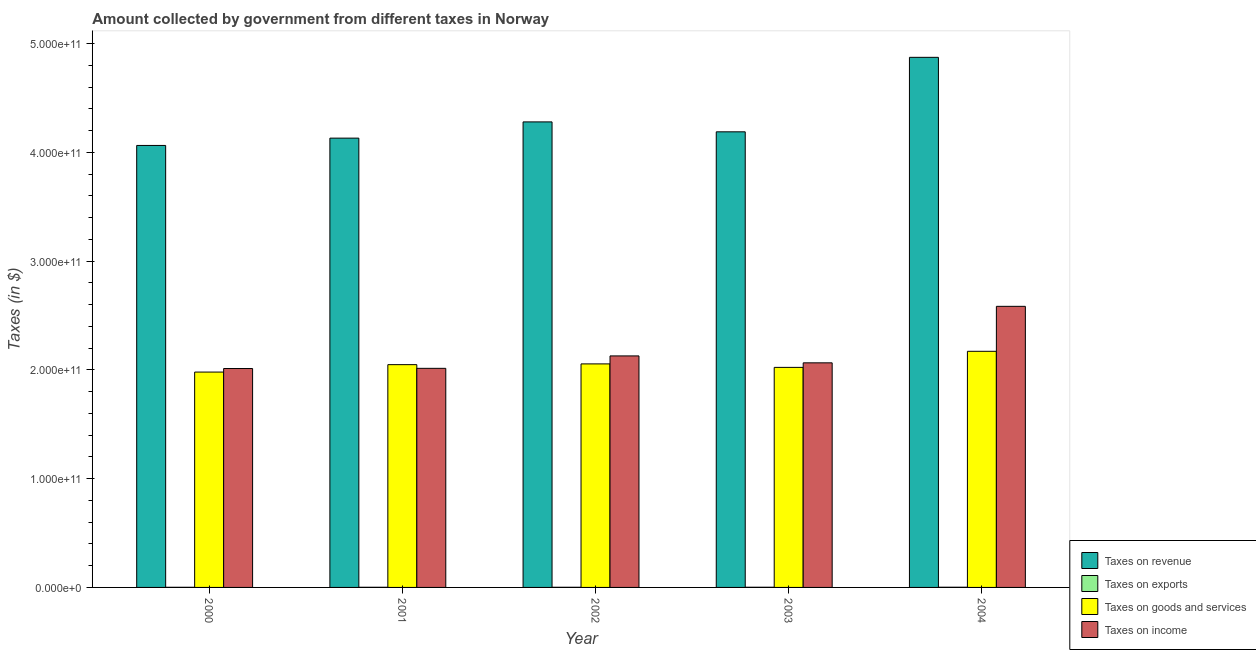How many groups of bars are there?
Give a very brief answer. 5. Are the number of bars on each tick of the X-axis equal?
Your response must be concise. Yes. How many bars are there on the 3rd tick from the right?
Keep it short and to the point. 4. What is the label of the 3rd group of bars from the left?
Offer a very short reply. 2002. What is the amount collected as tax on goods in 2003?
Offer a terse response. 2.02e+11. Across all years, what is the maximum amount collected as tax on exports?
Your response must be concise. 1.70e+08. Across all years, what is the minimum amount collected as tax on exports?
Your response must be concise. 1.10e+08. In which year was the amount collected as tax on income maximum?
Make the answer very short. 2004. What is the total amount collected as tax on revenue in the graph?
Give a very brief answer. 2.15e+12. What is the difference between the amount collected as tax on income in 2003 and that in 2004?
Make the answer very short. -5.19e+1. What is the difference between the amount collected as tax on exports in 2002 and the amount collected as tax on income in 2001?
Give a very brief answer. 1.00e+07. What is the average amount collected as tax on income per year?
Provide a short and direct response. 2.16e+11. In how many years, is the amount collected as tax on revenue greater than 40000000000 $?
Give a very brief answer. 5. What is the ratio of the amount collected as tax on income in 2002 to that in 2003?
Provide a succinct answer. 1.03. Is the amount collected as tax on goods in 2002 less than that in 2004?
Your answer should be very brief. Yes. Is the difference between the amount collected as tax on income in 2001 and 2004 greater than the difference between the amount collected as tax on revenue in 2001 and 2004?
Your response must be concise. No. What is the difference between the highest and the second highest amount collected as tax on goods?
Give a very brief answer. 1.16e+1. What is the difference between the highest and the lowest amount collected as tax on income?
Keep it short and to the point. 5.72e+1. What does the 4th bar from the left in 2001 represents?
Offer a terse response. Taxes on income. What does the 3rd bar from the right in 2004 represents?
Offer a terse response. Taxes on exports. Is it the case that in every year, the sum of the amount collected as tax on revenue and amount collected as tax on exports is greater than the amount collected as tax on goods?
Give a very brief answer. Yes. How many bars are there?
Offer a very short reply. 20. What is the difference between two consecutive major ticks on the Y-axis?
Ensure brevity in your answer.  1.00e+11. Does the graph contain grids?
Your answer should be very brief. No. Where does the legend appear in the graph?
Keep it short and to the point. Bottom right. How many legend labels are there?
Your response must be concise. 4. How are the legend labels stacked?
Give a very brief answer. Vertical. What is the title of the graph?
Your response must be concise. Amount collected by government from different taxes in Norway. Does "Korea" appear as one of the legend labels in the graph?
Give a very brief answer. No. What is the label or title of the X-axis?
Keep it short and to the point. Year. What is the label or title of the Y-axis?
Your answer should be very brief. Taxes (in $). What is the Taxes (in $) in Taxes on revenue in 2000?
Give a very brief answer. 4.06e+11. What is the Taxes (in $) in Taxes on exports in 2000?
Keep it short and to the point. 1.10e+08. What is the Taxes (in $) of Taxes on goods and services in 2000?
Provide a short and direct response. 1.98e+11. What is the Taxes (in $) of Taxes on income in 2000?
Your answer should be compact. 2.01e+11. What is the Taxes (in $) of Taxes on revenue in 2001?
Make the answer very short. 4.13e+11. What is the Taxes (in $) in Taxes on exports in 2001?
Your answer should be compact. 1.20e+08. What is the Taxes (in $) of Taxes on goods and services in 2001?
Give a very brief answer. 2.05e+11. What is the Taxes (in $) in Taxes on income in 2001?
Your answer should be compact. 2.01e+11. What is the Taxes (in $) in Taxes on revenue in 2002?
Offer a terse response. 4.28e+11. What is the Taxes (in $) of Taxes on exports in 2002?
Keep it short and to the point. 1.30e+08. What is the Taxes (in $) of Taxes on goods and services in 2002?
Give a very brief answer. 2.06e+11. What is the Taxes (in $) in Taxes on income in 2002?
Keep it short and to the point. 2.13e+11. What is the Taxes (in $) of Taxes on revenue in 2003?
Offer a terse response. 4.19e+11. What is the Taxes (in $) in Taxes on exports in 2003?
Make the answer very short. 1.50e+08. What is the Taxes (in $) of Taxes on goods and services in 2003?
Give a very brief answer. 2.02e+11. What is the Taxes (in $) in Taxes on income in 2003?
Ensure brevity in your answer.  2.06e+11. What is the Taxes (in $) in Taxes on revenue in 2004?
Make the answer very short. 4.87e+11. What is the Taxes (in $) of Taxes on exports in 2004?
Offer a very short reply. 1.70e+08. What is the Taxes (in $) in Taxes on goods and services in 2004?
Make the answer very short. 2.17e+11. What is the Taxes (in $) of Taxes on income in 2004?
Provide a short and direct response. 2.58e+11. Across all years, what is the maximum Taxes (in $) of Taxes on revenue?
Offer a very short reply. 4.87e+11. Across all years, what is the maximum Taxes (in $) in Taxes on exports?
Keep it short and to the point. 1.70e+08. Across all years, what is the maximum Taxes (in $) in Taxes on goods and services?
Your response must be concise. 2.17e+11. Across all years, what is the maximum Taxes (in $) of Taxes on income?
Your answer should be compact. 2.58e+11. Across all years, what is the minimum Taxes (in $) in Taxes on revenue?
Provide a short and direct response. 4.06e+11. Across all years, what is the minimum Taxes (in $) of Taxes on exports?
Make the answer very short. 1.10e+08. Across all years, what is the minimum Taxes (in $) of Taxes on goods and services?
Offer a very short reply. 1.98e+11. Across all years, what is the minimum Taxes (in $) in Taxes on income?
Give a very brief answer. 2.01e+11. What is the total Taxes (in $) in Taxes on revenue in the graph?
Offer a terse response. 2.15e+12. What is the total Taxes (in $) in Taxes on exports in the graph?
Give a very brief answer. 6.80e+08. What is the total Taxes (in $) of Taxes on goods and services in the graph?
Provide a short and direct response. 1.03e+12. What is the total Taxes (in $) of Taxes on income in the graph?
Your response must be concise. 1.08e+12. What is the difference between the Taxes (in $) in Taxes on revenue in 2000 and that in 2001?
Offer a terse response. -6.72e+09. What is the difference between the Taxes (in $) of Taxes on exports in 2000 and that in 2001?
Provide a succinct answer. -1.00e+07. What is the difference between the Taxes (in $) of Taxes on goods and services in 2000 and that in 2001?
Provide a short and direct response. -6.82e+09. What is the difference between the Taxes (in $) of Taxes on income in 2000 and that in 2001?
Your answer should be very brief. -1.79e+08. What is the difference between the Taxes (in $) of Taxes on revenue in 2000 and that in 2002?
Provide a succinct answer. -2.16e+1. What is the difference between the Taxes (in $) of Taxes on exports in 2000 and that in 2002?
Provide a short and direct response. -2.00e+07. What is the difference between the Taxes (in $) of Taxes on goods and services in 2000 and that in 2002?
Ensure brevity in your answer.  -7.52e+09. What is the difference between the Taxes (in $) of Taxes on income in 2000 and that in 2002?
Offer a very short reply. -1.16e+1. What is the difference between the Taxes (in $) in Taxes on revenue in 2000 and that in 2003?
Keep it short and to the point. -1.25e+1. What is the difference between the Taxes (in $) of Taxes on exports in 2000 and that in 2003?
Offer a terse response. -4.00e+07. What is the difference between the Taxes (in $) of Taxes on goods and services in 2000 and that in 2003?
Give a very brief answer. -4.31e+09. What is the difference between the Taxes (in $) in Taxes on income in 2000 and that in 2003?
Your answer should be compact. -5.23e+09. What is the difference between the Taxes (in $) in Taxes on revenue in 2000 and that in 2004?
Offer a terse response. -8.10e+1. What is the difference between the Taxes (in $) of Taxes on exports in 2000 and that in 2004?
Offer a terse response. -6.00e+07. What is the difference between the Taxes (in $) in Taxes on goods and services in 2000 and that in 2004?
Offer a very short reply. -1.91e+1. What is the difference between the Taxes (in $) of Taxes on income in 2000 and that in 2004?
Give a very brief answer. -5.72e+1. What is the difference between the Taxes (in $) in Taxes on revenue in 2001 and that in 2002?
Keep it short and to the point. -1.49e+1. What is the difference between the Taxes (in $) of Taxes on exports in 2001 and that in 2002?
Your response must be concise. -1.00e+07. What is the difference between the Taxes (in $) in Taxes on goods and services in 2001 and that in 2002?
Your answer should be compact. -6.98e+08. What is the difference between the Taxes (in $) in Taxes on income in 2001 and that in 2002?
Your response must be concise. -1.14e+1. What is the difference between the Taxes (in $) in Taxes on revenue in 2001 and that in 2003?
Your answer should be very brief. -5.80e+09. What is the difference between the Taxes (in $) of Taxes on exports in 2001 and that in 2003?
Offer a terse response. -3.00e+07. What is the difference between the Taxes (in $) in Taxes on goods and services in 2001 and that in 2003?
Make the answer very short. 2.51e+09. What is the difference between the Taxes (in $) of Taxes on income in 2001 and that in 2003?
Ensure brevity in your answer.  -5.05e+09. What is the difference between the Taxes (in $) of Taxes on revenue in 2001 and that in 2004?
Keep it short and to the point. -7.43e+1. What is the difference between the Taxes (in $) in Taxes on exports in 2001 and that in 2004?
Your answer should be very brief. -5.00e+07. What is the difference between the Taxes (in $) of Taxes on goods and services in 2001 and that in 2004?
Offer a very short reply. -1.23e+1. What is the difference between the Taxes (in $) of Taxes on income in 2001 and that in 2004?
Provide a succinct answer. -5.70e+1. What is the difference between the Taxes (in $) in Taxes on revenue in 2002 and that in 2003?
Provide a short and direct response. 9.12e+09. What is the difference between the Taxes (in $) of Taxes on exports in 2002 and that in 2003?
Your response must be concise. -2.00e+07. What is the difference between the Taxes (in $) in Taxes on goods and services in 2002 and that in 2003?
Your answer should be very brief. 3.21e+09. What is the difference between the Taxes (in $) in Taxes on income in 2002 and that in 2003?
Your response must be concise. 6.36e+09. What is the difference between the Taxes (in $) of Taxes on revenue in 2002 and that in 2004?
Keep it short and to the point. -5.94e+1. What is the difference between the Taxes (in $) in Taxes on exports in 2002 and that in 2004?
Your answer should be compact. -4.00e+07. What is the difference between the Taxes (in $) of Taxes on goods and services in 2002 and that in 2004?
Your answer should be very brief. -1.16e+1. What is the difference between the Taxes (in $) in Taxes on income in 2002 and that in 2004?
Your response must be concise. -4.56e+1. What is the difference between the Taxes (in $) in Taxes on revenue in 2003 and that in 2004?
Provide a short and direct response. -6.85e+1. What is the difference between the Taxes (in $) in Taxes on exports in 2003 and that in 2004?
Offer a very short reply. -2.00e+07. What is the difference between the Taxes (in $) of Taxes on goods and services in 2003 and that in 2004?
Your answer should be compact. -1.48e+1. What is the difference between the Taxes (in $) of Taxes on income in 2003 and that in 2004?
Give a very brief answer. -5.19e+1. What is the difference between the Taxes (in $) in Taxes on revenue in 2000 and the Taxes (in $) in Taxes on exports in 2001?
Your answer should be compact. 4.06e+11. What is the difference between the Taxes (in $) of Taxes on revenue in 2000 and the Taxes (in $) of Taxes on goods and services in 2001?
Ensure brevity in your answer.  2.02e+11. What is the difference between the Taxes (in $) in Taxes on revenue in 2000 and the Taxes (in $) in Taxes on income in 2001?
Offer a terse response. 2.05e+11. What is the difference between the Taxes (in $) of Taxes on exports in 2000 and the Taxes (in $) of Taxes on goods and services in 2001?
Give a very brief answer. -2.05e+11. What is the difference between the Taxes (in $) of Taxes on exports in 2000 and the Taxes (in $) of Taxes on income in 2001?
Keep it short and to the point. -2.01e+11. What is the difference between the Taxes (in $) of Taxes on goods and services in 2000 and the Taxes (in $) of Taxes on income in 2001?
Provide a succinct answer. -3.44e+09. What is the difference between the Taxes (in $) of Taxes on revenue in 2000 and the Taxes (in $) of Taxes on exports in 2002?
Your response must be concise. 4.06e+11. What is the difference between the Taxes (in $) of Taxes on revenue in 2000 and the Taxes (in $) of Taxes on goods and services in 2002?
Your response must be concise. 2.01e+11. What is the difference between the Taxes (in $) in Taxes on revenue in 2000 and the Taxes (in $) in Taxes on income in 2002?
Make the answer very short. 1.94e+11. What is the difference between the Taxes (in $) of Taxes on exports in 2000 and the Taxes (in $) of Taxes on goods and services in 2002?
Make the answer very short. -2.05e+11. What is the difference between the Taxes (in $) of Taxes on exports in 2000 and the Taxes (in $) of Taxes on income in 2002?
Offer a very short reply. -2.13e+11. What is the difference between the Taxes (in $) in Taxes on goods and services in 2000 and the Taxes (in $) in Taxes on income in 2002?
Offer a very short reply. -1.49e+1. What is the difference between the Taxes (in $) in Taxes on revenue in 2000 and the Taxes (in $) in Taxes on exports in 2003?
Your answer should be compact. 4.06e+11. What is the difference between the Taxes (in $) of Taxes on revenue in 2000 and the Taxes (in $) of Taxes on goods and services in 2003?
Provide a succinct answer. 2.04e+11. What is the difference between the Taxes (in $) in Taxes on revenue in 2000 and the Taxes (in $) in Taxes on income in 2003?
Your response must be concise. 2.00e+11. What is the difference between the Taxes (in $) of Taxes on exports in 2000 and the Taxes (in $) of Taxes on goods and services in 2003?
Keep it short and to the point. -2.02e+11. What is the difference between the Taxes (in $) of Taxes on exports in 2000 and the Taxes (in $) of Taxes on income in 2003?
Offer a terse response. -2.06e+11. What is the difference between the Taxes (in $) of Taxes on goods and services in 2000 and the Taxes (in $) of Taxes on income in 2003?
Offer a very short reply. -8.50e+09. What is the difference between the Taxes (in $) in Taxes on revenue in 2000 and the Taxes (in $) in Taxes on exports in 2004?
Keep it short and to the point. 4.06e+11. What is the difference between the Taxes (in $) of Taxes on revenue in 2000 and the Taxes (in $) of Taxes on goods and services in 2004?
Your response must be concise. 1.89e+11. What is the difference between the Taxes (in $) in Taxes on revenue in 2000 and the Taxes (in $) in Taxes on income in 2004?
Provide a succinct answer. 1.48e+11. What is the difference between the Taxes (in $) of Taxes on exports in 2000 and the Taxes (in $) of Taxes on goods and services in 2004?
Make the answer very short. -2.17e+11. What is the difference between the Taxes (in $) in Taxes on exports in 2000 and the Taxes (in $) in Taxes on income in 2004?
Your answer should be very brief. -2.58e+11. What is the difference between the Taxes (in $) in Taxes on goods and services in 2000 and the Taxes (in $) in Taxes on income in 2004?
Keep it short and to the point. -6.04e+1. What is the difference between the Taxes (in $) in Taxes on revenue in 2001 and the Taxes (in $) in Taxes on exports in 2002?
Your answer should be compact. 4.13e+11. What is the difference between the Taxes (in $) in Taxes on revenue in 2001 and the Taxes (in $) in Taxes on goods and services in 2002?
Ensure brevity in your answer.  2.08e+11. What is the difference between the Taxes (in $) in Taxes on revenue in 2001 and the Taxes (in $) in Taxes on income in 2002?
Provide a succinct answer. 2.00e+11. What is the difference between the Taxes (in $) in Taxes on exports in 2001 and the Taxes (in $) in Taxes on goods and services in 2002?
Your response must be concise. -2.05e+11. What is the difference between the Taxes (in $) of Taxes on exports in 2001 and the Taxes (in $) of Taxes on income in 2002?
Make the answer very short. -2.13e+11. What is the difference between the Taxes (in $) in Taxes on goods and services in 2001 and the Taxes (in $) in Taxes on income in 2002?
Your answer should be compact. -8.03e+09. What is the difference between the Taxes (in $) of Taxes on revenue in 2001 and the Taxes (in $) of Taxes on exports in 2003?
Offer a terse response. 4.13e+11. What is the difference between the Taxes (in $) of Taxes on revenue in 2001 and the Taxes (in $) of Taxes on goods and services in 2003?
Offer a terse response. 2.11e+11. What is the difference between the Taxes (in $) in Taxes on revenue in 2001 and the Taxes (in $) in Taxes on income in 2003?
Provide a short and direct response. 2.07e+11. What is the difference between the Taxes (in $) of Taxes on exports in 2001 and the Taxes (in $) of Taxes on goods and services in 2003?
Ensure brevity in your answer.  -2.02e+11. What is the difference between the Taxes (in $) in Taxes on exports in 2001 and the Taxes (in $) in Taxes on income in 2003?
Your answer should be very brief. -2.06e+11. What is the difference between the Taxes (in $) of Taxes on goods and services in 2001 and the Taxes (in $) of Taxes on income in 2003?
Make the answer very short. -1.67e+09. What is the difference between the Taxes (in $) of Taxes on revenue in 2001 and the Taxes (in $) of Taxes on exports in 2004?
Provide a succinct answer. 4.13e+11. What is the difference between the Taxes (in $) of Taxes on revenue in 2001 and the Taxes (in $) of Taxes on goods and services in 2004?
Provide a short and direct response. 1.96e+11. What is the difference between the Taxes (in $) in Taxes on revenue in 2001 and the Taxes (in $) in Taxes on income in 2004?
Offer a very short reply. 1.55e+11. What is the difference between the Taxes (in $) in Taxes on exports in 2001 and the Taxes (in $) in Taxes on goods and services in 2004?
Provide a succinct answer. -2.17e+11. What is the difference between the Taxes (in $) in Taxes on exports in 2001 and the Taxes (in $) in Taxes on income in 2004?
Your answer should be compact. -2.58e+11. What is the difference between the Taxes (in $) of Taxes on goods and services in 2001 and the Taxes (in $) of Taxes on income in 2004?
Provide a short and direct response. -5.36e+1. What is the difference between the Taxes (in $) in Taxes on revenue in 2002 and the Taxes (in $) in Taxes on exports in 2003?
Keep it short and to the point. 4.28e+11. What is the difference between the Taxes (in $) in Taxes on revenue in 2002 and the Taxes (in $) in Taxes on goods and services in 2003?
Your response must be concise. 2.26e+11. What is the difference between the Taxes (in $) in Taxes on revenue in 2002 and the Taxes (in $) in Taxes on income in 2003?
Offer a terse response. 2.22e+11. What is the difference between the Taxes (in $) in Taxes on exports in 2002 and the Taxes (in $) in Taxes on goods and services in 2003?
Your response must be concise. -2.02e+11. What is the difference between the Taxes (in $) in Taxes on exports in 2002 and the Taxes (in $) in Taxes on income in 2003?
Offer a terse response. -2.06e+11. What is the difference between the Taxes (in $) in Taxes on goods and services in 2002 and the Taxes (in $) in Taxes on income in 2003?
Keep it short and to the point. -9.76e+08. What is the difference between the Taxes (in $) in Taxes on revenue in 2002 and the Taxes (in $) in Taxes on exports in 2004?
Your answer should be very brief. 4.28e+11. What is the difference between the Taxes (in $) in Taxes on revenue in 2002 and the Taxes (in $) in Taxes on goods and services in 2004?
Make the answer very short. 2.11e+11. What is the difference between the Taxes (in $) of Taxes on revenue in 2002 and the Taxes (in $) of Taxes on income in 2004?
Ensure brevity in your answer.  1.70e+11. What is the difference between the Taxes (in $) in Taxes on exports in 2002 and the Taxes (in $) in Taxes on goods and services in 2004?
Offer a very short reply. -2.17e+11. What is the difference between the Taxes (in $) of Taxes on exports in 2002 and the Taxes (in $) of Taxes on income in 2004?
Make the answer very short. -2.58e+11. What is the difference between the Taxes (in $) of Taxes on goods and services in 2002 and the Taxes (in $) of Taxes on income in 2004?
Provide a short and direct response. -5.29e+1. What is the difference between the Taxes (in $) of Taxes on revenue in 2003 and the Taxes (in $) of Taxes on exports in 2004?
Your response must be concise. 4.19e+11. What is the difference between the Taxes (in $) of Taxes on revenue in 2003 and the Taxes (in $) of Taxes on goods and services in 2004?
Keep it short and to the point. 2.02e+11. What is the difference between the Taxes (in $) in Taxes on revenue in 2003 and the Taxes (in $) in Taxes on income in 2004?
Make the answer very short. 1.60e+11. What is the difference between the Taxes (in $) in Taxes on exports in 2003 and the Taxes (in $) in Taxes on goods and services in 2004?
Provide a succinct answer. -2.17e+11. What is the difference between the Taxes (in $) of Taxes on exports in 2003 and the Taxes (in $) of Taxes on income in 2004?
Provide a succinct answer. -2.58e+11. What is the difference between the Taxes (in $) of Taxes on goods and services in 2003 and the Taxes (in $) of Taxes on income in 2004?
Offer a terse response. -5.61e+1. What is the average Taxes (in $) of Taxes on revenue per year?
Give a very brief answer. 4.31e+11. What is the average Taxes (in $) of Taxes on exports per year?
Keep it short and to the point. 1.36e+08. What is the average Taxes (in $) of Taxes on goods and services per year?
Ensure brevity in your answer.  2.06e+11. What is the average Taxes (in $) in Taxes on income per year?
Your answer should be very brief. 2.16e+11. In the year 2000, what is the difference between the Taxes (in $) in Taxes on revenue and Taxes (in $) in Taxes on exports?
Give a very brief answer. 4.06e+11. In the year 2000, what is the difference between the Taxes (in $) in Taxes on revenue and Taxes (in $) in Taxes on goods and services?
Your response must be concise. 2.08e+11. In the year 2000, what is the difference between the Taxes (in $) in Taxes on revenue and Taxes (in $) in Taxes on income?
Your answer should be very brief. 2.05e+11. In the year 2000, what is the difference between the Taxes (in $) in Taxes on exports and Taxes (in $) in Taxes on goods and services?
Provide a short and direct response. -1.98e+11. In the year 2000, what is the difference between the Taxes (in $) in Taxes on exports and Taxes (in $) in Taxes on income?
Make the answer very short. -2.01e+11. In the year 2000, what is the difference between the Taxes (in $) of Taxes on goods and services and Taxes (in $) of Taxes on income?
Provide a succinct answer. -3.26e+09. In the year 2001, what is the difference between the Taxes (in $) in Taxes on revenue and Taxes (in $) in Taxes on exports?
Give a very brief answer. 4.13e+11. In the year 2001, what is the difference between the Taxes (in $) in Taxes on revenue and Taxes (in $) in Taxes on goods and services?
Provide a succinct answer. 2.08e+11. In the year 2001, what is the difference between the Taxes (in $) of Taxes on revenue and Taxes (in $) of Taxes on income?
Ensure brevity in your answer.  2.12e+11. In the year 2001, what is the difference between the Taxes (in $) of Taxes on exports and Taxes (in $) of Taxes on goods and services?
Offer a very short reply. -2.05e+11. In the year 2001, what is the difference between the Taxes (in $) of Taxes on exports and Taxes (in $) of Taxes on income?
Offer a terse response. -2.01e+11. In the year 2001, what is the difference between the Taxes (in $) in Taxes on goods and services and Taxes (in $) in Taxes on income?
Your response must be concise. 3.38e+09. In the year 2002, what is the difference between the Taxes (in $) of Taxes on revenue and Taxes (in $) of Taxes on exports?
Offer a very short reply. 4.28e+11. In the year 2002, what is the difference between the Taxes (in $) of Taxes on revenue and Taxes (in $) of Taxes on goods and services?
Your answer should be very brief. 2.22e+11. In the year 2002, what is the difference between the Taxes (in $) in Taxes on revenue and Taxes (in $) in Taxes on income?
Offer a very short reply. 2.15e+11. In the year 2002, what is the difference between the Taxes (in $) in Taxes on exports and Taxes (in $) in Taxes on goods and services?
Ensure brevity in your answer.  -2.05e+11. In the year 2002, what is the difference between the Taxes (in $) of Taxes on exports and Taxes (in $) of Taxes on income?
Your answer should be very brief. -2.13e+11. In the year 2002, what is the difference between the Taxes (in $) of Taxes on goods and services and Taxes (in $) of Taxes on income?
Make the answer very short. -7.34e+09. In the year 2003, what is the difference between the Taxes (in $) of Taxes on revenue and Taxes (in $) of Taxes on exports?
Keep it short and to the point. 4.19e+11. In the year 2003, what is the difference between the Taxes (in $) in Taxes on revenue and Taxes (in $) in Taxes on goods and services?
Ensure brevity in your answer.  2.17e+11. In the year 2003, what is the difference between the Taxes (in $) in Taxes on revenue and Taxes (in $) in Taxes on income?
Give a very brief answer. 2.12e+11. In the year 2003, what is the difference between the Taxes (in $) in Taxes on exports and Taxes (in $) in Taxes on goods and services?
Give a very brief answer. -2.02e+11. In the year 2003, what is the difference between the Taxes (in $) in Taxes on exports and Taxes (in $) in Taxes on income?
Ensure brevity in your answer.  -2.06e+11. In the year 2003, what is the difference between the Taxes (in $) in Taxes on goods and services and Taxes (in $) in Taxes on income?
Your response must be concise. -4.18e+09. In the year 2004, what is the difference between the Taxes (in $) of Taxes on revenue and Taxes (in $) of Taxes on exports?
Your answer should be very brief. 4.87e+11. In the year 2004, what is the difference between the Taxes (in $) in Taxes on revenue and Taxes (in $) in Taxes on goods and services?
Ensure brevity in your answer.  2.70e+11. In the year 2004, what is the difference between the Taxes (in $) of Taxes on revenue and Taxes (in $) of Taxes on income?
Provide a succinct answer. 2.29e+11. In the year 2004, what is the difference between the Taxes (in $) of Taxes on exports and Taxes (in $) of Taxes on goods and services?
Your response must be concise. -2.17e+11. In the year 2004, what is the difference between the Taxes (in $) in Taxes on exports and Taxes (in $) in Taxes on income?
Keep it short and to the point. -2.58e+11. In the year 2004, what is the difference between the Taxes (in $) in Taxes on goods and services and Taxes (in $) in Taxes on income?
Offer a very short reply. -4.13e+1. What is the ratio of the Taxes (in $) of Taxes on revenue in 2000 to that in 2001?
Provide a short and direct response. 0.98. What is the ratio of the Taxes (in $) in Taxes on exports in 2000 to that in 2001?
Make the answer very short. 0.92. What is the ratio of the Taxes (in $) in Taxes on goods and services in 2000 to that in 2001?
Give a very brief answer. 0.97. What is the ratio of the Taxes (in $) of Taxes on income in 2000 to that in 2001?
Your response must be concise. 1. What is the ratio of the Taxes (in $) in Taxes on revenue in 2000 to that in 2002?
Give a very brief answer. 0.95. What is the ratio of the Taxes (in $) of Taxes on exports in 2000 to that in 2002?
Your answer should be compact. 0.85. What is the ratio of the Taxes (in $) of Taxes on goods and services in 2000 to that in 2002?
Offer a terse response. 0.96. What is the ratio of the Taxes (in $) of Taxes on income in 2000 to that in 2002?
Offer a terse response. 0.95. What is the ratio of the Taxes (in $) of Taxes on revenue in 2000 to that in 2003?
Provide a short and direct response. 0.97. What is the ratio of the Taxes (in $) in Taxes on exports in 2000 to that in 2003?
Your answer should be very brief. 0.73. What is the ratio of the Taxes (in $) in Taxes on goods and services in 2000 to that in 2003?
Keep it short and to the point. 0.98. What is the ratio of the Taxes (in $) in Taxes on income in 2000 to that in 2003?
Your answer should be very brief. 0.97. What is the ratio of the Taxes (in $) of Taxes on revenue in 2000 to that in 2004?
Your answer should be compact. 0.83. What is the ratio of the Taxes (in $) in Taxes on exports in 2000 to that in 2004?
Offer a terse response. 0.65. What is the ratio of the Taxes (in $) of Taxes on goods and services in 2000 to that in 2004?
Give a very brief answer. 0.91. What is the ratio of the Taxes (in $) in Taxes on income in 2000 to that in 2004?
Offer a terse response. 0.78. What is the ratio of the Taxes (in $) in Taxes on revenue in 2001 to that in 2002?
Provide a short and direct response. 0.97. What is the ratio of the Taxes (in $) of Taxes on income in 2001 to that in 2002?
Your answer should be compact. 0.95. What is the ratio of the Taxes (in $) of Taxes on revenue in 2001 to that in 2003?
Make the answer very short. 0.99. What is the ratio of the Taxes (in $) of Taxes on goods and services in 2001 to that in 2003?
Make the answer very short. 1.01. What is the ratio of the Taxes (in $) in Taxes on income in 2001 to that in 2003?
Provide a succinct answer. 0.98. What is the ratio of the Taxes (in $) in Taxes on revenue in 2001 to that in 2004?
Give a very brief answer. 0.85. What is the ratio of the Taxes (in $) in Taxes on exports in 2001 to that in 2004?
Offer a terse response. 0.71. What is the ratio of the Taxes (in $) of Taxes on goods and services in 2001 to that in 2004?
Provide a succinct answer. 0.94. What is the ratio of the Taxes (in $) in Taxes on income in 2001 to that in 2004?
Provide a succinct answer. 0.78. What is the ratio of the Taxes (in $) in Taxes on revenue in 2002 to that in 2003?
Offer a terse response. 1.02. What is the ratio of the Taxes (in $) in Taxes on exports in 2002 to that in 2003?
Offer a terse response. 0.87. What is the ratio of the Taxes (in $) of Taxes on goods and services in 2002 to that in 2003?
Your answer should be very brief. 1.02. What is the ratio of the Taxes (in $) of Taxes on income in 2002 to that in 2003?
Offer a terse response. 1.03. What is the ratio of the Taxes (in $) in Taxes on revenue in 2002 to that in 2004?
Make the answer very short. 0.88. What is the ratio of the Taxes (in $) of Taxes on exports in 2002 to that in 2004?
Offer a very short reply. 0.76. What is the ratio of the Taxes (in $) of Taxes on goods and services in 2002 to that in 2004?
Your response must be concise. 0.95. What is the ratio of the Taxes (in $) of Taxes on income in 2002 to that in 2004?
Offer a terse response. 0.82. What is the ratio of the Taxes (in $) in Taxes on revenue in 2003 to that in 2004?
Offer a very short reply. 0.86. What is the ratio of the Taxes (in $) in Taxes on exports in 2003 to that in 2004?
Give a very brief answer. 0.88. What is the ratio of the Taxes (in $) in Taxes on goods and services in 2003 to that in 2004?
Your response must be concise. 0.93. What is the ratio of the Taxes (in $) of Taxes on income in 2003 to that in 2004?
Your answer should be very brief. 0.8. What is the difference between the highest and the second highest Taxes (in $) in Taxes on revenue?
Your answer should be very brief. 5.94e+1. What is the difference between the highest and the second highest Taxes (in $) in Taxes on exports?
Offer a terse response. 2.00e+07. What is the difference between the highest and the second highest Taxes (in $) in Taxes on goods and services?
Provide a succinct answer. 1.16e+1. What is the difference between the highest and the second highest Taxes (in $) of Taxes on income?
Keep it short and to the point. 4.56e+1. What is the difference between the highest and the lowest Taxes (in $) in Taxes on revenue?
Your answer should be compact. 8.10e+1. What is the difference between the highest and the lowest Taxes (in $) of Taxes on exports?
Offer a terse response. 6.00e+07. What is the difference between the highest and the lowest Taxes (in $) in Taxes on goods and services?
Ensure brevity in your answer.  1.91e+1. What is the difference between the highest and the lowest Taxes (in $) in Taxes on income?
Your response must be concise. 5.72e+1. 